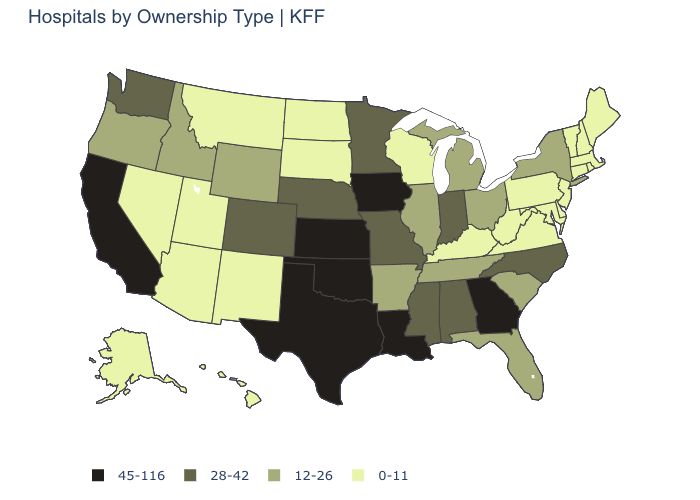What is the highest value in the Northeast ?
Be succinct. 12-26. Is the legend a continuous bar?
Concise answer only. No. Which states have the lowest value in the USA?
Be succinct. Alaska, Arizona, Connecticut, Delaware, Hawaii, Kentucky, Maine, Maryland, Massachusetts, Montana, Nevada, New Hampshire, New Jersey, New Mexico, North Dakota, Pennsylvania, Rhode Island, South Dakota, Utah, Vermont, Virginia, West Virginia, Wisconsin. Which states have the lowest value in the USA?
Short answer required. Alaska, Arizona, Connecticut, Delaware, Hawaii, Kentucky, Maine, Maryland, Massachusetts, Montana, Nevada, New Hampshire, New Jersey, New Mexico, North Dakota, Pennsylvania, Rhode Island, South Dakota, Utah, Vermont, Virginia, West Virginia, Wisconsin. Does the map have missing data?
Short answer required. No. Among the states that border Alabama , which have the highest value?
Quick response, please. Georgia. Does Virginia have the lowest value in the USA?
Write a very short answer. Yes. Does Ohio have the highest value in the MidWest?
Quick response, please. No. Which states have the lowest value in the USA?
Keep it brief. Alaska, Arizona, Connecticut, Delaware, Hawaii, Kentucky, Maine, Maryland, Massachusetts, Montana, Nevada, New Hampshire, New Jersey, New Mexico, North Dakota, Pennsylvania, Rhode Island, South Dakota, Utah, Vermont, Virginia, West Virginia, Wisconsin. Name the states that have a value in the range 45-116?
Answer briefly. California, Georgia, Iowa, Kansas, Louisiana, Oklahoma, Texas. Does North Dakota have the lowest value in the USA?
Be succinct. Yes. What is the highest value in the USA?
Concise answer only. 45-116. What is the highest value in states that border Georgia?
Answer briefly. 28-42. What is the highest value in the South ?
Be succinct. 45-116. Which states hav the highest value in the South?
Answer briefly. Georgia, Louisiana, Oklahoma, Texas. 